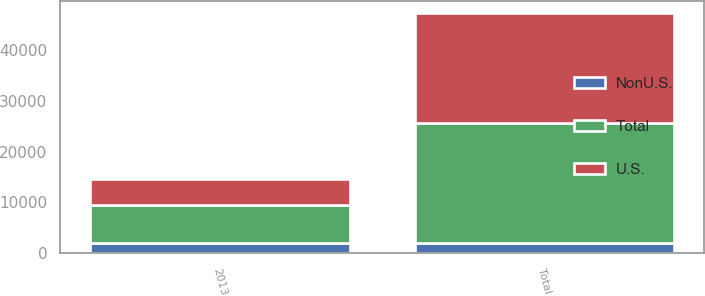Convert chart. <chart><loc_0><loc_0><loc_500><loc_500><stacked_bar_chart><ecel><fcel>2013<fcel>Total<nl><fcel>U.S.<fcel>5248<fcel>21532<nl><fcel>NonU.S.<fcel>2083<fcel>2083<nl><fcel>Total<fcel>7331<fcel>23615<nl></chart> 